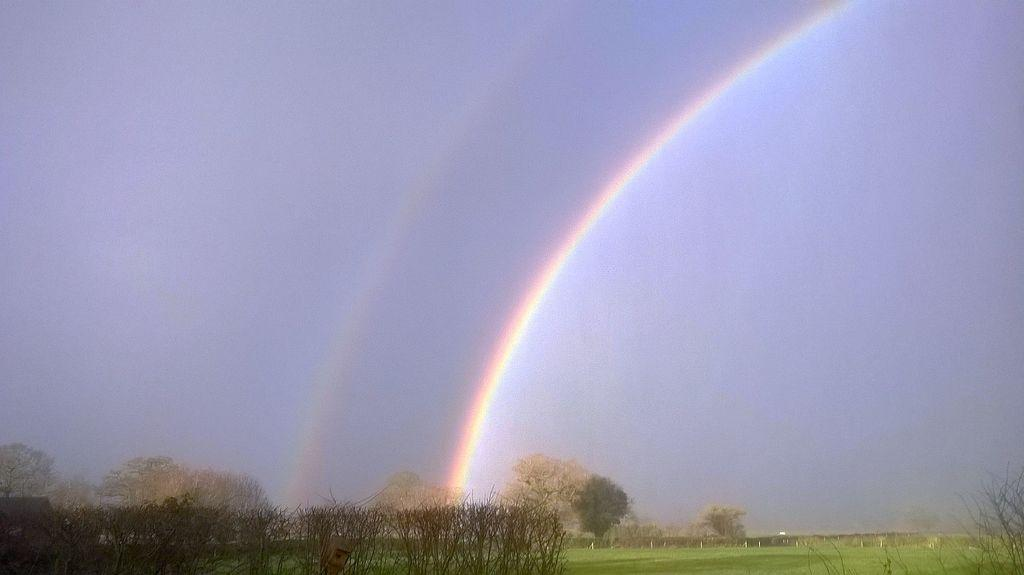What type of vegetation can be seen in the image? There are trees in the image. What is covering the ground in the image? There is grass on the ground in the image. What part of the natural environment is visible in the image? The sky is visible in the background of the image. What additional feature can be seen in the sky? A rainbow is present in the sky. How many times has the coil been crushed and folded in the image? There is no coil present in the image, so it cannot be crushed or folded. 